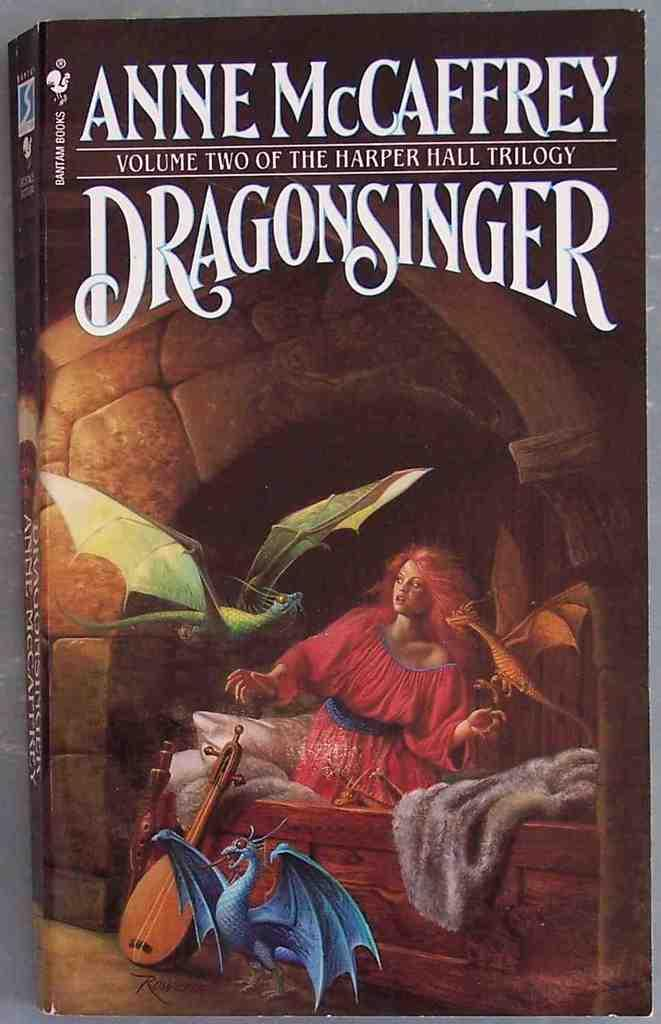Provide a one-sentence caption for the provided image. The book cover artwork for Dragonsinger by Anne McCaffrey. 